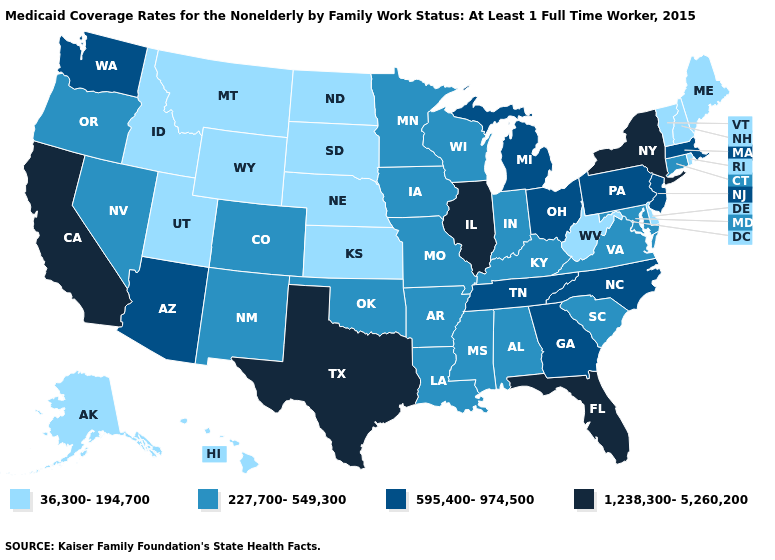Name the states that have a value in the range 595,400-974,500?
Short answer required. Arizona, Georgia, Massachusetts, Michigan, New Jersey, North Carolina, Ohio, Pennsylvania, Tennessee, Washington. Does Maryland have a higher value than Delaware?
Keep it brief. Yes. Which states have the lowest value in the Northeast?
Answer briefly. Maine, New Hampshire, Rhode Island, Vermont. What is the highest value in states that border Idaho?
Write a very short answer. 595,400-974,500. What is the highest value in the Northeast ?
Write a very short answer. 1,238,300-5,260,200. What is the value of Montana?
Give a very brief answer. 36,300-194,700. Does the first symbol in the legend represent the smallest category?
Be succinct. Yes. Name the states that have a value in the range 595,400-974,500?
Quick response, please. Arizona, Georgia, Massachusetts, Michigan, New Jersey, North Carolina, Ohio, Pennsylvania, Tennessee, Washington. What is the value of New Jersey?
Answer briefly. 595,400-974,500. Name the states that have a value in the range 595,400-974,500?
Quick response, please. Arizona, Georgia, Massachusetts, Michigan, New Jersey, North Carolina, Ohio, Pennsylvania, Tennessee, Washington. Name the states that have a value in the range 595,400-974,500?
Write a very short answer. Arizona, Georgia, Massachusetts, Michigan, New Jersey, North Carolina, Ohio, Pennsylvania, Tennessee, Washington. Does the first symbol in the legend represent the smallest category?
Keep it brief. Yes. Among the states that border Alabama , which have the highest value?
Concise answer only. Florida. What is the highest value in states that border Arkansas?
Give a very brief answer. 1,238,300-5,260,200. What is the value of Montana?
Quick response, please. 36,300-194,700. 